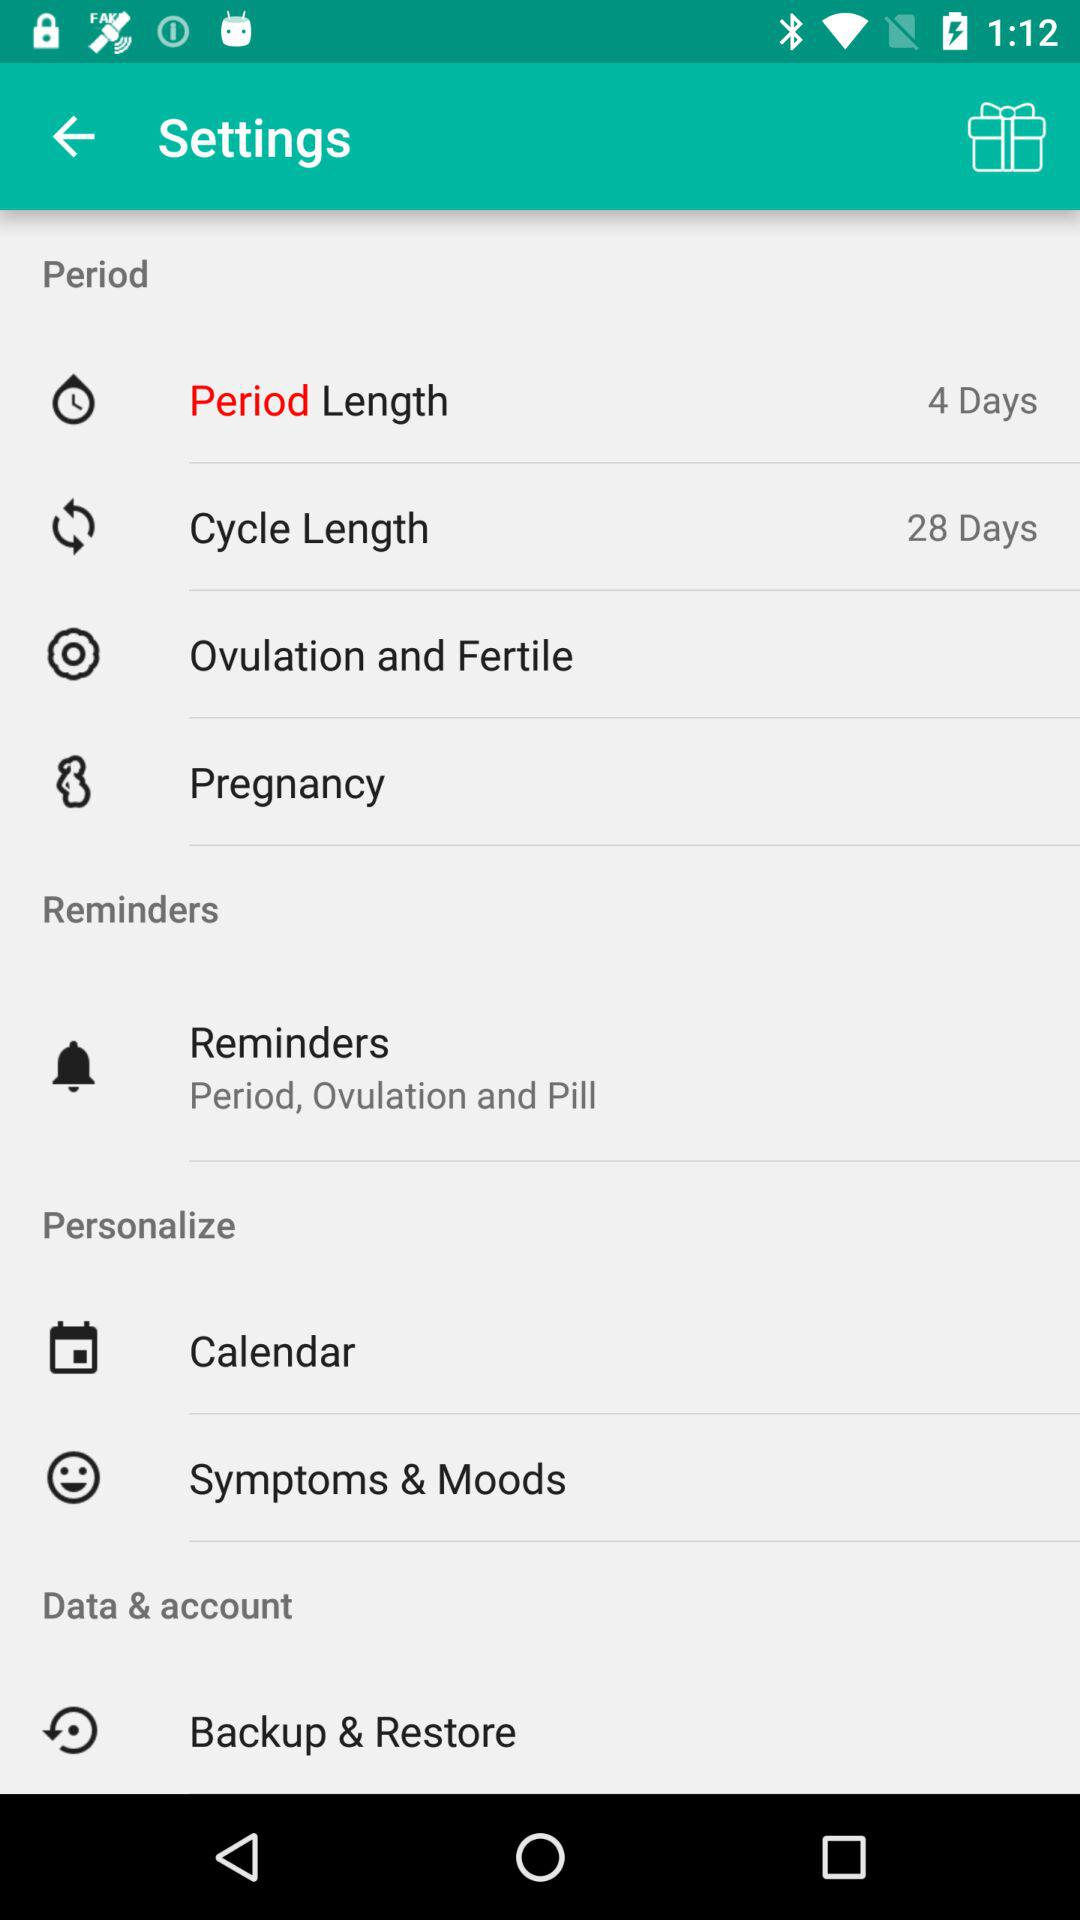What is the cycle length? The cycle length is 28 days. 